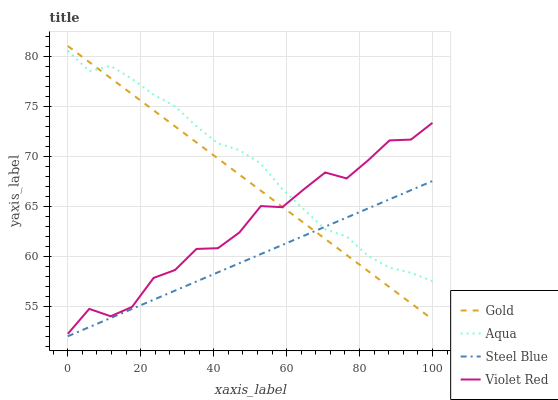Does Steel Blue have the minimum area under the curve?
Answer yes or no. Yes. Does Aqua have the maximum area under the curve?
Answer yes or no. Yes. Does Aqua have the minimum area under the curve?
Answer yes or no. No. Does Steel Blue have the maximum area under the curve?
Answer yes or no. No. Is Gold the smoothest?
Answer yes or no. Yes. Is Violet Red the roughest?
Answer yes or no. Yes. Is Aqua the smoothest?
Answer yes or no. No. Is Aqua the roughest?
Answer yes or no. No. Does Aqua have the lowest value?
Answer yes or no. No. Does Gold have the highest value?
Answer yes or no. Yes. Does Aqua have the highest value?
Answer yes or no. No. Is Steel Blue less than Violet Red?
Answer yes or no. Yes. Is Violet Red greater than Steel Blue?
Answer yes or no. Yes. Does Aqua intersect Gold?
Answer yes or no. Yes. Is Aqua less than Gold?
Answer yes or no. No. Is Aqua greater than Gold?
Answer yes or no. No. Does Steel Blue intersect Violet Red?
Answer yes or no. No. 